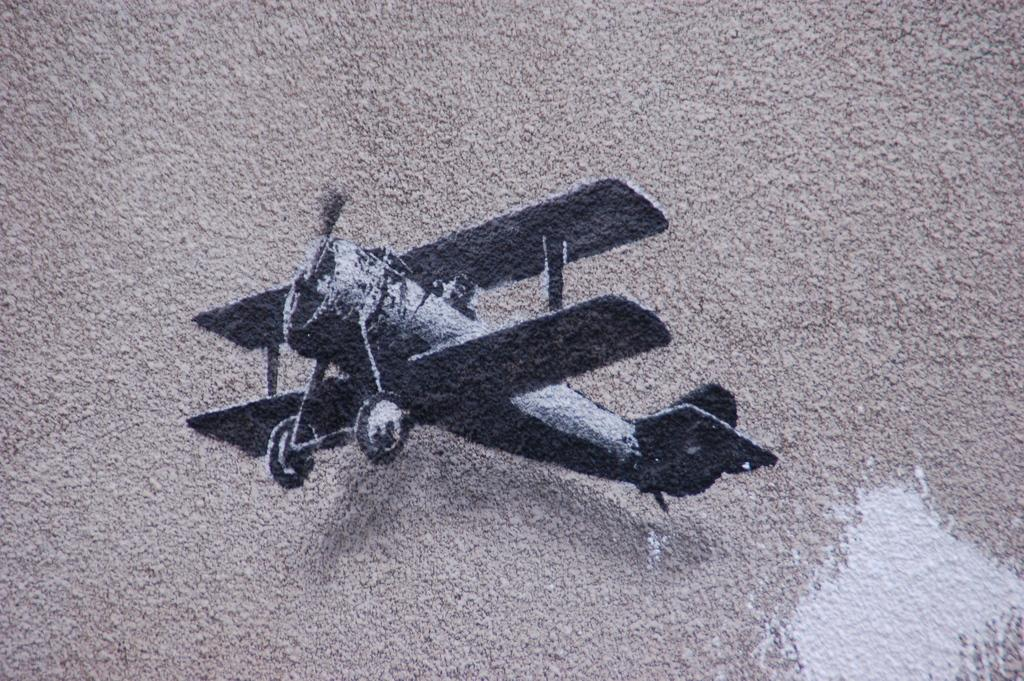What is the main subject of the image? The main subject of the image is a wall. What is featured on the wall in the image? There is a painting of an aircraft on the wall. How many kittens are playing with a thumb in the image? There are no kittens or thumbs present in the image; it features a wall with a painting of an aircraft. 